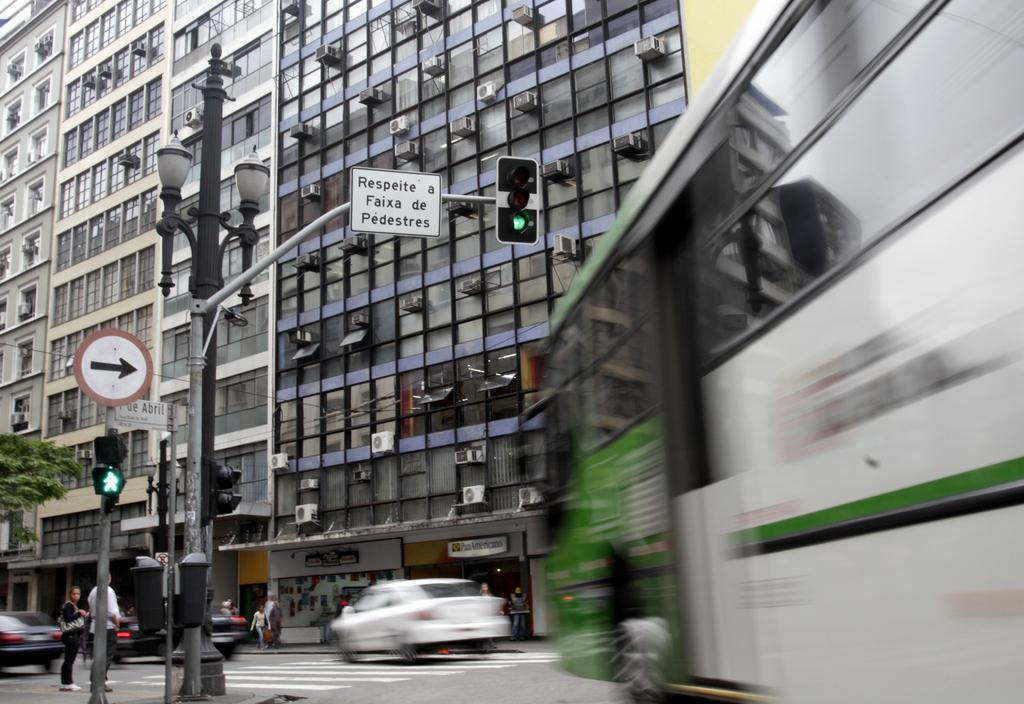What can be seen on the road in the image? There are vehicles on the road in the image. Who or what else is present in the image? There are people in the image. What type of lighting is present in the image? There is a pole light in the image. What helps regulate traffic in the image? Traffic signal lights are present in the image. What safety measure is visible in the image? There is a caution board in the image. What can be seen in the background of the image? There is a building in the background of the image. What type of silk is being produced in the image? There is no silk or silk production visible in the image. What industry is represented in the image? The image does not depict a specific industry. 